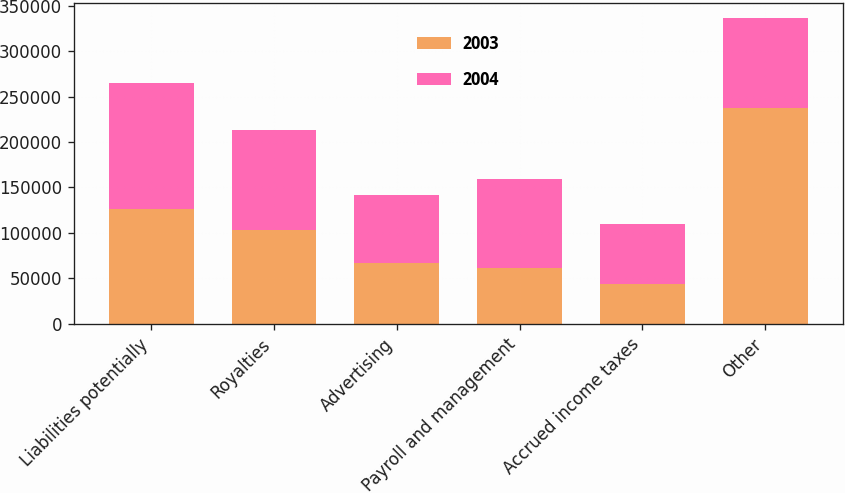<chart> <loc_0><loc_0><loc_500><loc_500><stacked_bar_chart><ecel><fcel>Liabilities potentially<fcel>Royalties<fcel>Advertising<fcel>Payroll and management<fcel>Accrued income taxes<fcel>Other<nl><fcel>2003<fcel>125940<fcel>103206<fcel>67181<fcel>61009<fcel>43648<fcel>237959<nl><fcel>2004<fcel>138650<fcel>110210<fcel>74849<fcel>98103<fcel>66080<fcel>98103<nl></chart> 